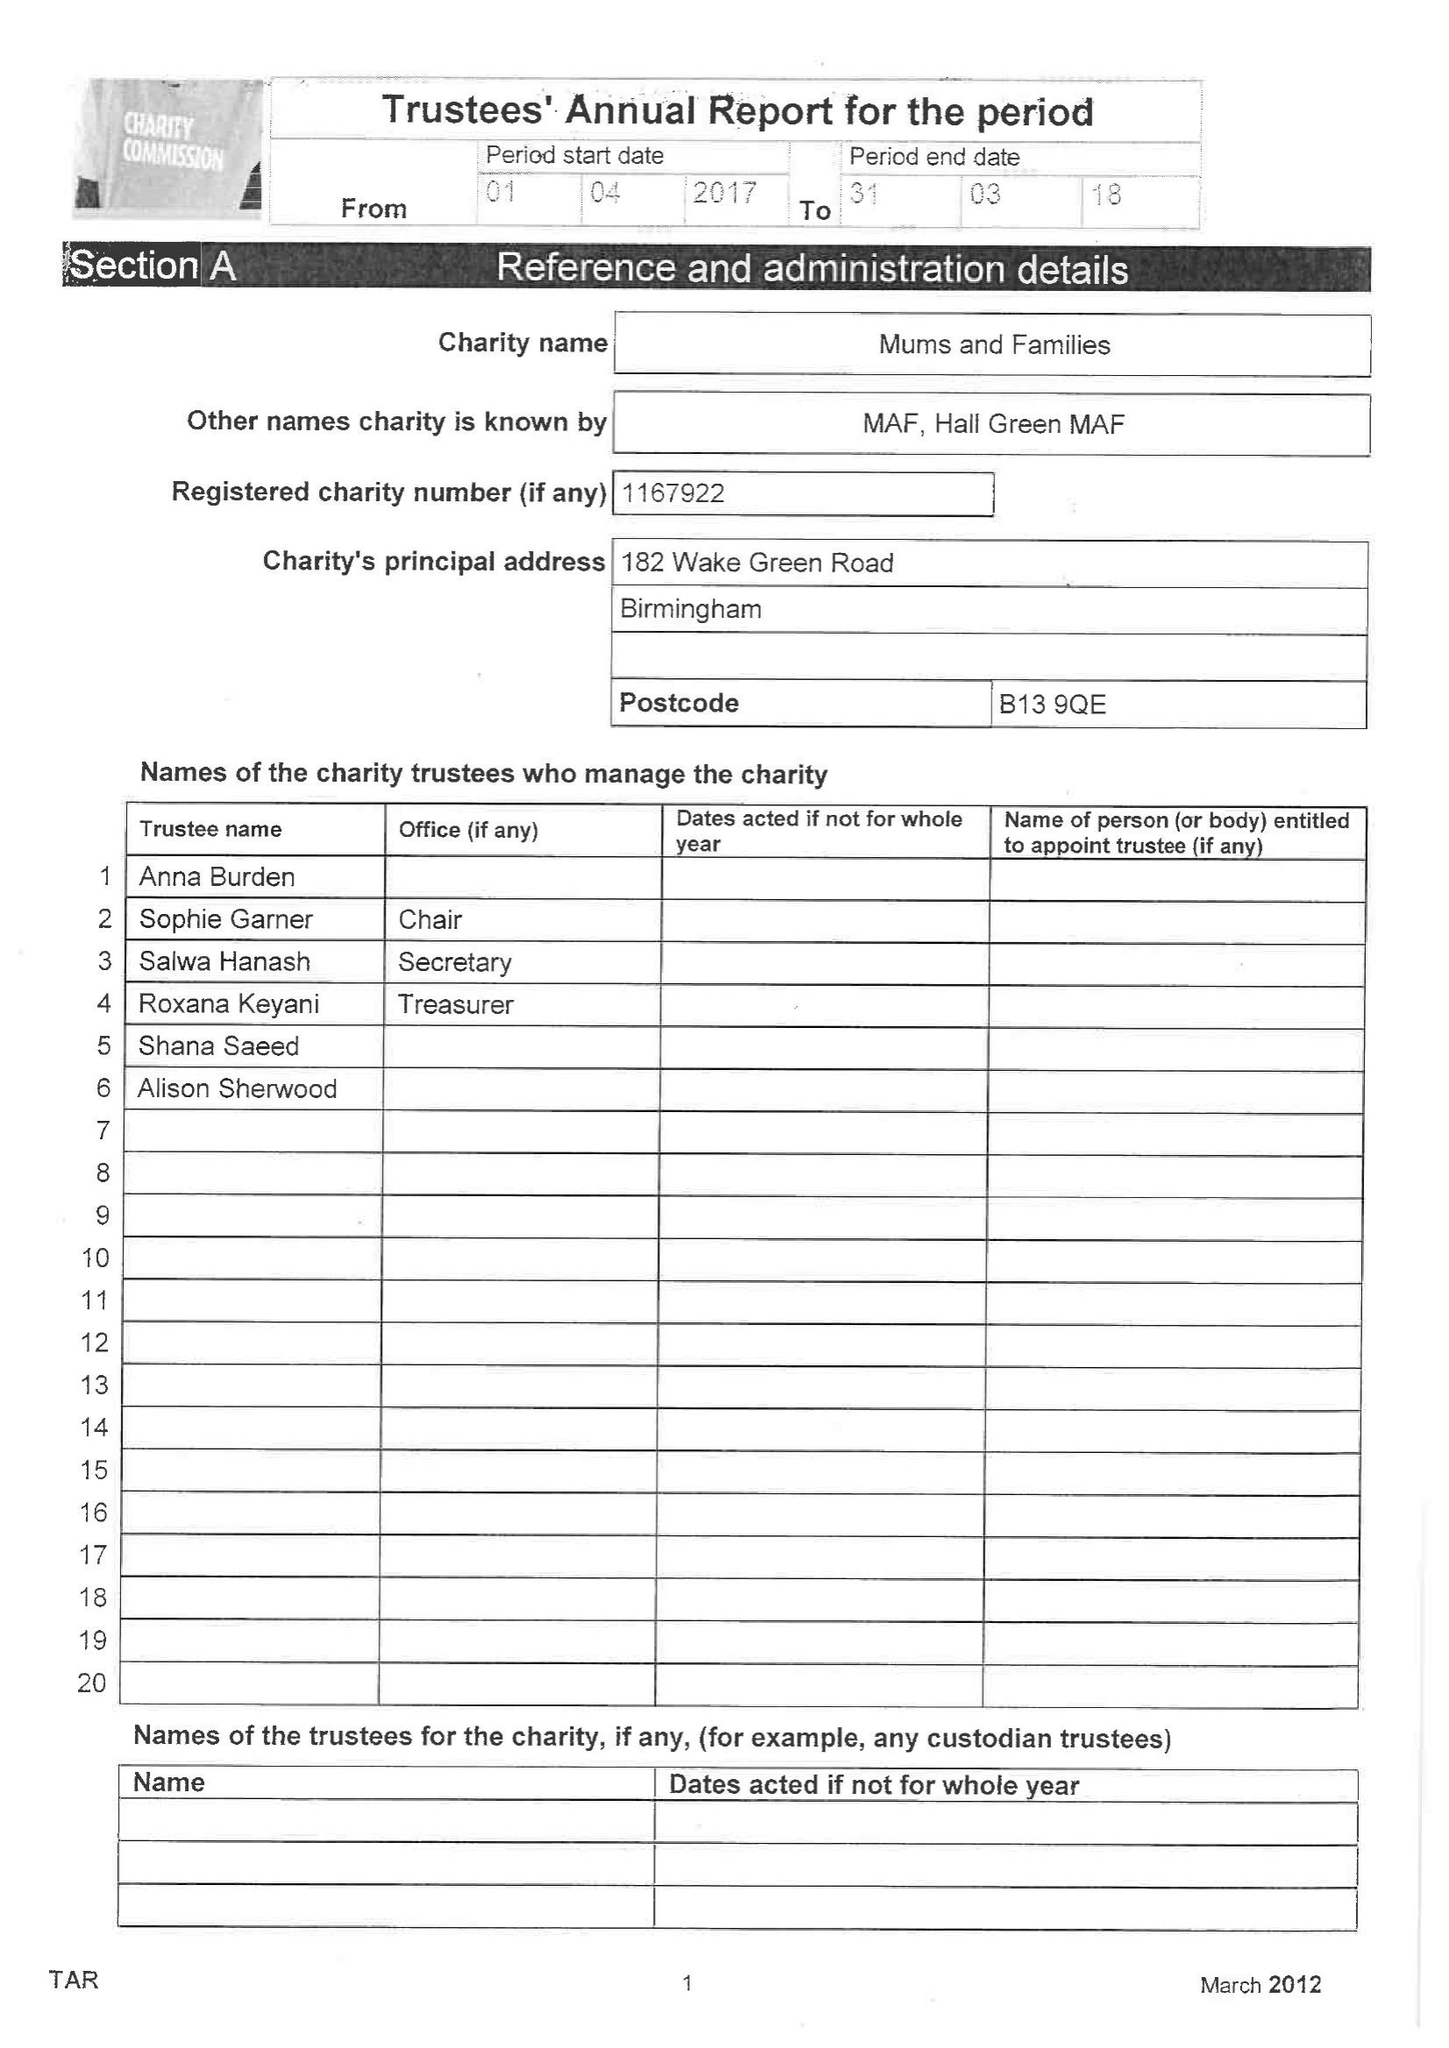What is the value for the charity_name?
Answer the question using a single word or phrase. Mums and Families 